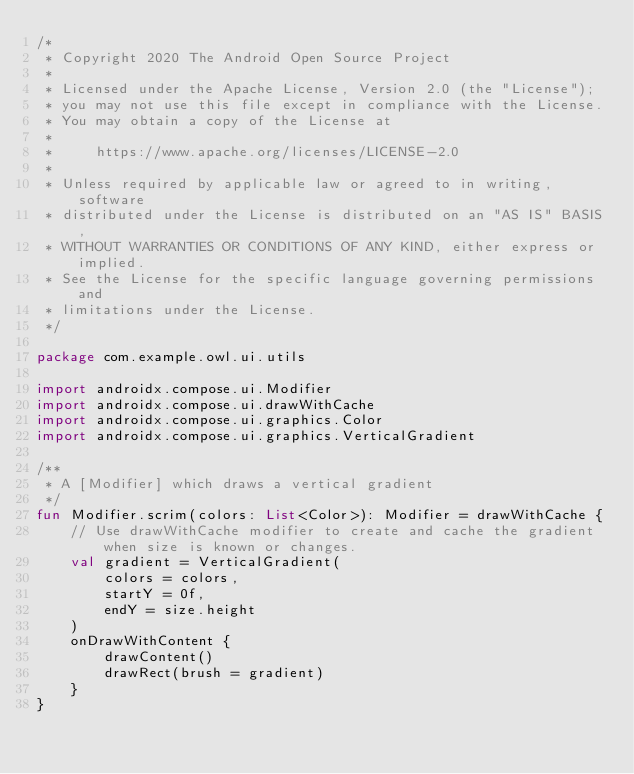<code> <loc_0><loc_0><loc_500><loc_500><_Kotlin_>/*
 * Copyright 2020 The Android Open Source Project
 *
 * Licensed under the Apache License, Version 2.0 (the "License");
 * you may not use this file except in compliance with the License.
 * You may obtain a copy of the License at
 *
 *     https://www.apache.org/licenses/LICENSE-2.0
 *
 * Unless required by applicable law or agreed to in writing, software
 * distributed under the License is distributed on an "AS IS" BASIS,
 * WITHOUT WARRANTIES OR CONDITIONS OF ANY KIND, either express or implied.
 * See the License for the specific language governing permissions and
 * limitations under the License.
 */

package com.example.owl.ui.utils

import androidx.compose.ui.Modifier
import androidx.compose.ui.drawWithCache
import androidx.compose.ui.graphics.Color
import androidx.compose.ui.graphics.VerticalGradient

/**
 * A [Modifier] which draws a vertical gradient
 */
fun Modifier.scrim(colors: List<Color>): Modifier = drawWithCache {
    // Use drawWithCache modifier to create and cache the gradient when size is known or changes.
    val gradient = VerticalGradient(
        colors = colors,
        startY = 0f,
        endY = size.height
    )
    onDrawWithContent {
        drawContent()
        drawRect(brush = gradient)
    }
}
</code> 